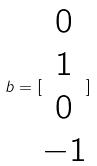Convert formula to latex. <formula><loc_0><loc_0><loc_500><loc_500>b = [ \begin{matrix} 0 \\ 1 \\ 0 \\ - 1 \end{matrix} ]</formula> 